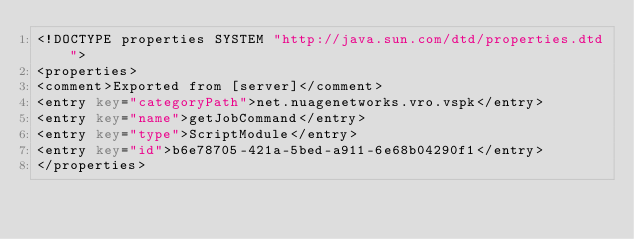Convert code to text. <code><loc_0><loc_0><loc_500><loc_500><_XML_><!DOCTYPE properties SYSTEM "http://java.sun.com/dtd/properties.dtd">
<properties>
<comment>Exported from [server]</comment>
<entry key="categoryPath">net.nuagenetworks.vro.vspk</entry>
<entry key="name">getJobCommand</entry>
<entry key="type">ScriptModule</entry>
<entry key="id">b6e78705-421a-5bed-a911-6e68b04290f1</entry>
</properties></code> 